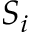<formula> <loc_0><loc_0><loc_500><loc_500>S _ { i }</formula> 